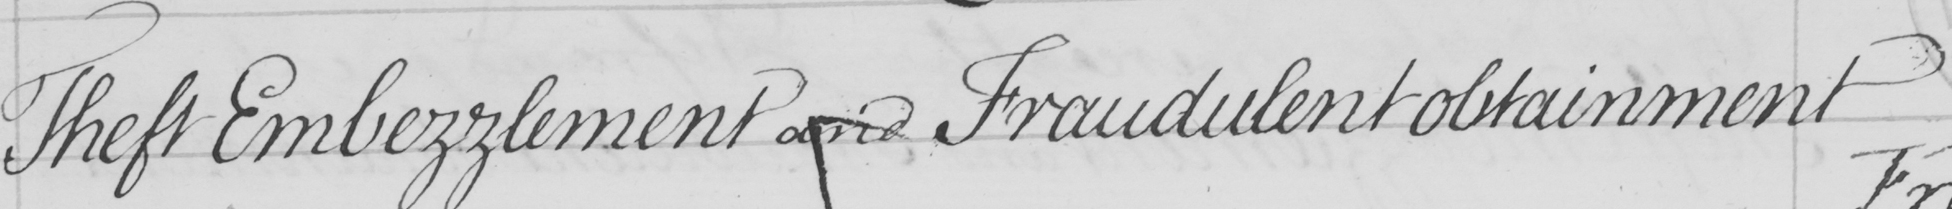Please provide the text content of this handwritten line. Theft Embezzlement and Fraudulent obtainment 